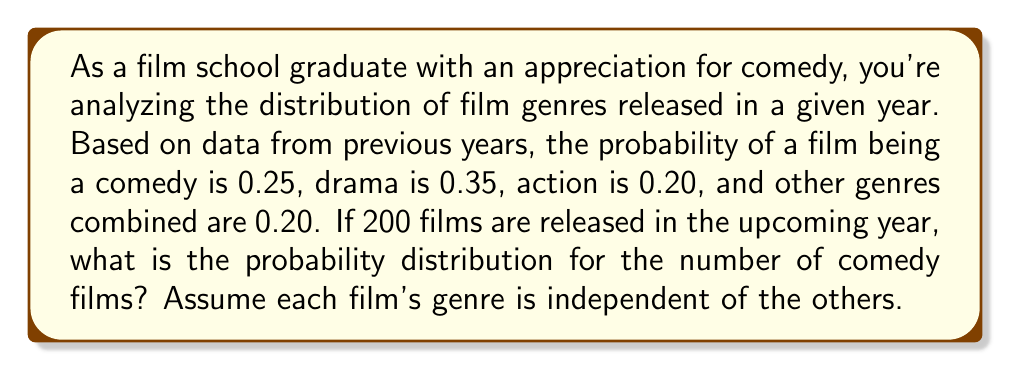Solve this math problem. To solve this problem, we need to recognize that this scenario follows a binomial distribution. Here's why:

1. We have a fixed number of trials (200 films).
2. Each trial has two possible outcomes (comedy or not comedy).
3. The probability of success (a film being a comedy) is constant (0.25).
4. Each trial is independent.

The binomial distribution is given by the probability mass function:

$$P(X = k) = \binom{n}{k} p^k (1-p)^{n-k}$$

Where:
- $n$ is the number of trials (200 films)
- $k$ is the number of successes (number of comedy films)
- $p$ is the probability of success on each trial (0.25)

To find the probability distribution, we need to calculate this for all possible values of $k$ from 0 to 200. However, for practical purposes, we'll focus on the most likely outcomes.

The mean of this distribution is:

$$\mu = np = 200 * 0.25 = 50$$

The standard deviation is:

$$\sigma = \sqrt{np(1-p)} = \sqrt{200 * 0.25 * 0.75} \approx 6.12$$

Most outcomes will fall within 3 standard deviations of the mean, so we'll calculate probabilities for $k$ from 32 to 68.

For example, the probability of exactly 50 comedy films:

$$P(X = 50) = \binom{200}{50} 0.25^{50} 0.75^{150} \approx 0.0508$$

We would repeat this calculation for each value of $k$ from 32 to 68 to get the full probability distribution.
Answer: Binomial distribution with $n=200$, $p=0.25$, mean $\mu=50$, standard deviation $\sigma \approx 6.12$ 